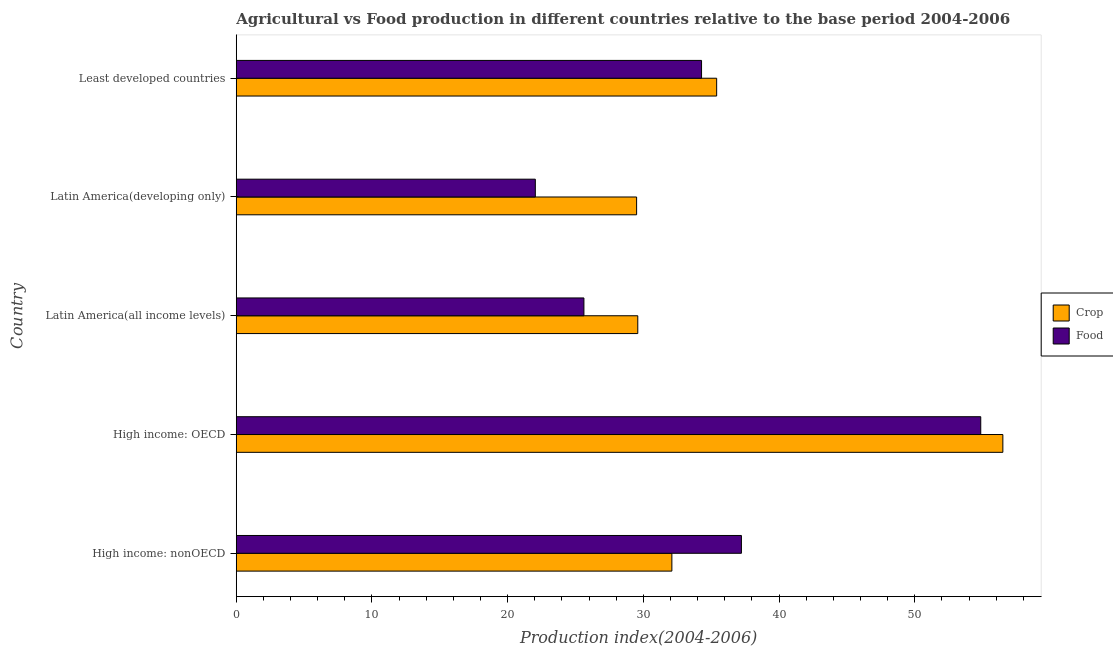How many different coloured bars are there?
Provide a short and direct response. 2. How many groups of bars are there?
Make the answer very short. 5. Are the number of bars on each tick of the Y-axis equal?
Keep it short and to the point. Yes. How many bars are there on the 3rd tick from the top?
Your response must be concise. 2. What is the label of the 3rd group of bars from the top?
Make the answer very short. Latin America(all income levels). In how many cases, is the number of bars for a given country not equal to the number of legend labels?
Ensure brevity in your answer.  0. What is the crop production index in High income: nonOECD?
Give a very brief answer. 32.1. Across all countries, what is the maximum food production index?
Ensure brevity in your answer.  54.86. Across all countries, what is the minimum food production index?
Keep it short and to the point. 22.04. In which country was the crop production index maximum?
Provide a short and direct response. High income: OECD. In which country was the food production index minimum?
Give a very brief answer. Latin America(developing only). What is the total food production index in the graph?
Your answer should be compact. 174.04. What is the difference between the crop production index in High income: OECD and that in Latin America(developing only)?
Offer a terse response. 26.99. What is the difference between the food production index in Least developed countries and the crop production index in High income: nonOECD?
Give a very brief answer. 2.19. What is the average food production index per country?
Give a very brief answer. 34.81. What is the difference between the crop production index and food production index in High income: nonOECD?
Offer a terse response. -5.12. In how many countries, is the crop production index greater than 26 ?
Keep it short and to the point. 5. What is the ratio of the food production index in Latin America(all income levels) to that in Least developed countries?
Your answer should be compact. 0.75. Is the food production index in High income: nonOECD less than that in Latin America(all income levels)?
Give a very brief answer. No. Is the difference between the food production index in High income: OECD and Least developed countries greater than the difference between the crop production index in High income: OECD and Least developed countries?
Provide a short and direct response. No. What is the difference between the highest and the second highest crop production index?
Make the answer very short. 21.09. What is the difference between the highest and the lowest crop production index?
Offer a very short reply. 26.99. In how many countries, is the food production index greater than the average food production index taken over all countries?
Your answer should be compact. 2. What does the 2nd bar from the top in Least developed countries represents?
Provide a short and direct response. Crop. What does the 1st bar from the bottom in High income: nonOECD represents?
Offer a terse response. Crop. How many countries are there in the graph?
Offer a very short reply. 5. Are the values on the major ticks of X-axis written in scientific E-notation?
Give a very brief answer. No. Does the graph contain any zero values?
Ensure brevity in your answer.  No. How many legend labels are there?
Your answer should be compact. 2. What is the title of the graph?
Keep it short and to the point. Agricultural vs Food production in different countries relative to the base period 2004-2006. What is the label or title of the X-axis?
Keep it short and to the point. Production index(2004-2006). What is the label or title of the Y-axis?
Provide a succinct answer. Country. What is the Production index(2004-2006) of Crop in High income: nonOECD?
Your answer should be very brief. 32.1. What is the Production index(2004-2006) of Food in High income: nonOECD?
Your answer should be compact. 37.23. What is the Production index(2004-2006) in Crop in High income: OECD?
Provide a succinct answer. 56.49. What is the Production index(2004-2006) in Food in High income: OECD?
Make the answer very short. 54.86. What is the Production index(2004-2006) of Crop in Latin America(all income levels)?
Provide a short and direct response. 29.59. What is the Production index(2004-2006) in Food in Latin America(all income levels)?
Offer a terse response. 25.62. What is the Production index(2004-2006) of Crop in Latin America(developing only)?
Provide a succinct answer. 29.5. What is the Production index(2004-2006) in Food in Latin America(developing only)?
Your response must be concise. 22.04. What is the Production index(2004-2006) of Crop in Least developed countries?
Give a very brief answer. 35.4. What is the Production index(2004-2006) in Food in Least developed countries?
Your answer should be very brief. 34.29. Across all countries, what is the maximum Production index(2004-2006) in Crop?
Offer a very short reply. 56.49. Across all countries, what is the maximum Production index(2004-2006) in Food?
Your answer should be compact. 54.86. Across all countries, what is the minimum Production index(2004-2006) of Crop?
Offer a very short reply. 29.5. Across all countries, what is the minimum Production index(2004-2006) in Food?
Ensure brevity in your answer.  22.04. What is the total Production index(2004-2006) in Crop in the graph?
Your answer should be compact. 183.09. What is the total Production index(2004-2006) in Food in the graph?
Your answer should be very brief. 174.04. What is the difference between the Production index(2004-2006) in Crop in High income: nonOECD and that in High income: OECD?
Offer a very short reply. -24.39. What is the difference between the Production index(2004-2006) of Food in High income: nonOECD and that in High income: OECD?
Offer a very short reply. -17.64. What is the difference between the Production index(2004-2006) of Crop in High income: nonOECD and that in Latin America(all income levels)?
Make the answer very short. 2.51. What is the difference between the Production index(2004-2006) in Food in High income: nonOECD and that in Latin America(all income levels)?
Your answer should be compact. 11.61. What is the difference between the Production index(2004-2006) of Crop in High income: nonOECD and that in Latin America(developing only)?
Make the answer very short. 2.6. What is the difference between the Production index(2004-2006) of Food in High income: nonOECD and that in Latin America(developing only)?
Offer a very short reply. 15.19. What is the difference between the Production index(2004-2006) in Crop in High income: nonOECD and that in Least developed countries?
Provide a short and direct response. -3.3. What is the difference between the Production index(2004-2006) of Food in High income: nonOECD and that in Least developed countries?
Your answer should be very brief. 2.94. What is the difference between the Production index(2004-2006) of Crop in High income: OECD and that in Latin America(all income levels)?
Offer a very short reply. 26.9. What is the difference between the Production index(2004-2006) in Food in High income: OECD and that in Latin America(all income levels)?
Keep it short and to the point. 29.24. What is the difference between the Production index(2004-2006) in Crop in High income: OECD and that in Latin America(developing only)?
Give a very brief answer. 26.99. What is the difference between the Production index(2004-2006) in Food in High income: OECD and that in Latin America(developing only)?
Offer a very short reply. 32.82. What is the difference between the Production index(2004-2006) of Crop in High income: OECD and that in Least developed countries?
Ensure brevity in your answer.  21.09. What is the difference between the Production index(2004-2006) of Food in High income: OECD and that in Least developed countries?
Provide a succinct answer. 20.57. What is the difference between the Production index(2004-2006) in Crop in Latin America(all income levels) and that in Latin America(developing only)?
Offer a terse response. 0.09. What is the difference between the Production index(2004-2006) of Food in Latin America(all income levels) and that in Latin America(developing only)?
Offer a very short reply. 3.58. What is the difference between the Production index(2004-2006) in Crop in Latin America(all income levels) and that in Least developed countries?
Your answer should be very brief. -5.81. What is the difference between the Production index(2004-2006) of Food in Latin America(all income levels) and that in Least developed countries?
Your answer should be compact. -8.67. What is the difference between the Production index(2004-2006) in Crop in Latin America(developing only) and that in Least developed countries?
Your answer should be very brief. -5.9. What is the difference between the Production index(2004-2006) of Food in Latin America(developing only) and that in Least developed countries?
Your answer should be compact. -12.25. What is the difference between the Production index(2004-2006) of Crop in High income: nonOECD and the Production index(2004-2006) of Food in High income: OECD?
Offer a very short reply. -22.76. What is the difference between the Production index(2004-2006) of Crop in High income: nonOECD and the Production index(2004-2006) of Food in Latin America(all income levels)?
Provide a short and direct response. 6.48. What is the difference between the Production index(2004-2006) of Crop in High income: nonOECD and the Production index(2004-2006) of Food in Latin America(developing only)?
Offer a terse response. 10.06. What is the difference between the Production index(2004-2006) in Crop in High income: nonOECD and the Production index(2004-2006) in Food in Least developed countries?
Keep it short and to the point. -2.19. What is the difference between the Production index(2004-2006) of Crop in High income: OECD and the Production index(2004-2006) of Food in Latin America(all income levels)?
Your response must be concise. 30.87. What is the difference between the Production index(2004-2006) of Crop in High income: OECD and the Production index(2004-2006) of Food in Latin America(developing only)?
Your response must be concise. 34.45. What is the difference between the Production index(2004-2006) in Crop in High income: OECD and the Production index(2004-2006) in Food in Least developed countries?
Your answer should be very brief. 22.2. What is the difference between the Production index(2004-2006) of Crop in Latin America(all income levels) and the Production index(2004-2006) of Food in Latin America(developing only)?
Give a very brief answer. 7.55. What is the difference between the Production index(2004-2006) of Crop in Latin America(all income levels) and the Production index(2004-2006) of Food in Least developed countries?
Your response must be concise. -4.7. What is the difference between the Production index(2004-2006) of Crop in Latin America(developing only) and the Production index(2004-2006) of Food in Least developed countries?
Your answer should be very brief. -4.79. What is the average Production index(2004-2006) in Crop per country?
Offer a terse response. 36.62. What is the average Production index(2004-2006) in Food per country?
Give a very brief answer. 34.81. What is the difference between the Production index(2004-2006) of Crop and Production index(2004-2006) of Food in High income: nonOECD?
Provide a succinct answer. -5.13. What is the difference between the Production index(2004-2006) of Crop and Production index(2004-2006) of Food in High income: OECD?
Provide a succinct answer. 1.63. What is the difference between the Production index(2004-2006) in Crop and Production index(2004-2006) in Food in Latin America(all income levels)?
Your answer should be compact. 3.97. What is the difference between the Production index(2004-2006) in Crop and Production index(2004-2006) in Food in Latin America(developing only)?
Provide a succinct answer. 7.46. What is the difference between the Production index(2004-2006) of Crop and Production index(2004-2006) of Food in Least developed countries?
Provide a succinct answer. 1.11. What is the ratio of the Production index(2004-2006) in Crop in High income: nonOECD to that in High income: OECD?
Your response must be concise. 0.57. What is the ratio of the Production index(2004-2006) of Food in High income: nonOECD to that in High income: OECD?
Provide a short and direct response. 0.68. What is the ratio of the Production index(2004-2006) in Crop in High income: nonOECD to that in Latin America(all income levels)?
Give a very brief answer. 1.08. What is the ratio of the Production index(2004-2006) in Food in High income: nonOECD to that in Latin America(all income levels)?
Keep it short and to the point. 1.45. What is the ratio of the Production index(2004-2006) of Crop in High income: nonOECD to that in Latin America(developing only)?
Keep it short and to the point. 1.09. What is the ratio of the Production index(2004-2006) of Food in High income: nonOECD to that in Latin America(developing only)?
Your answer should be very brief. 1.69. What is the ratio of the Production index(2004-2006) of Crop in High income: nonOECD to that in Least developed countries?
Your answer should be compact. 0.91. What is the ratio of the Production index(2004-2006) in Food in High income: nonOECD to that in Least developed countries?
Make the answer very short. 1.09. What is the ratio of the Production index(2004-2006) of Crop in High income: OECD to that in Latin America(all income levels)?
Ensure brevity in your answer.  1.91. What is the ratio of the Production index(2004-2006) in Food in High income: OECD to that in Latin America(all income levels)?
Your answer should be very brief. 2.14. What is the ratio of the Production index(2004-2006) of Crop in High income: OECD to that in Latin America(developing only)?
Provide a succinct answer. 1.91. What is the ratio of the Production index(2004-2006) in Food in High income: OECD to that in Latin America(developing only)?
Ensure brevity in your answer.  2.49. What is the ratio of the Production index(2004-2006) in Crop in High income: OECD to that in Least developed countries?
Your answer should be very brief. 1.6. What is the ratio of the Production index(2004-2006) of Food in High income: OECD to that in Least developed countries?
Your answer should be very brief. 1.6. What is the ratio of the Production index(2004-2006) of Crop in Latin America(all income levels) to that in Latin America(developing only)?
Your answer should be compact. 1. What is the ratio of the Production index(2004-2006) of Food in Latin America(all income levels) to that in Latin America(developing only)?
Make the answer very short. 1.16. What is the ratio of the Production index(2004-2006) of Crop in Latin America(all income levels) to that in Least developed countries?
Your answer should be very brief. 0.84. What is the ratio of the Production index(2004-2006) of Food in Latin America(all income levels) to that in Least developed countries?
Your answer should be compact. 0.75. What is the ratio of the Production index(2004-2006) in Crop in Latin America(developing only) to that in Least developed countries?
Keep it short and to the point. 0.83. What is the ratio of the Production index(2004-2006) in Food in Latin America(developing only) to that in Least developed countries?
Give a very brief answer. 0.64. What is the difference between the highest and the second highest Production index(2004-2006) of Crop?
Your answer should be compact. 21.09. What is the difference between the highest and the second highest Production index(2004-2006) of Food?
Your answer should be compact. 17.64. What is the difference between the highest and the lowest Production index(2004-2006) in Crop?
Ensure brevity in your answer.  26.99. What is the difference between the highest and the lowest Production index(2004-2006) in Food?
Keep it short and to the point. 32.82. 